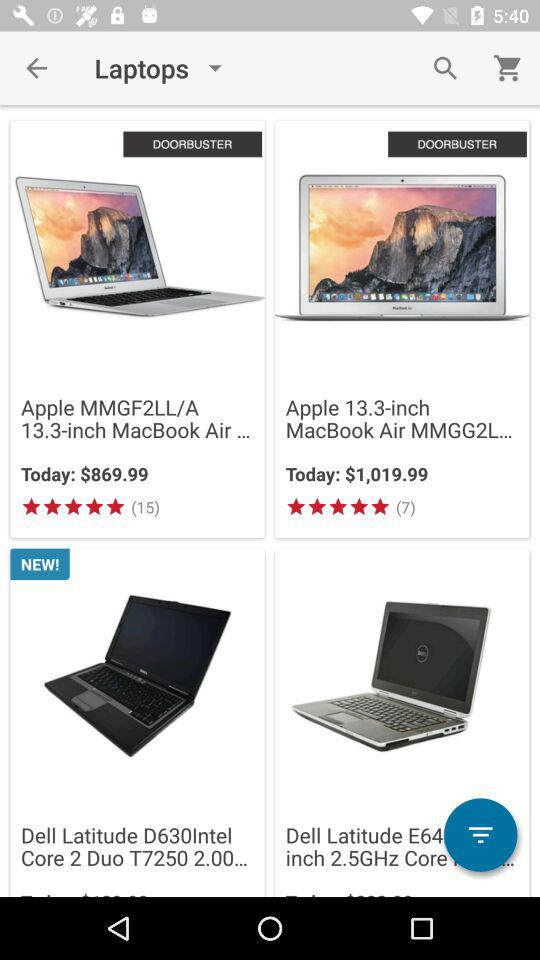How much more expensive is the second laptop than the first?
Answer the question using a single word or phrase. $150.00 